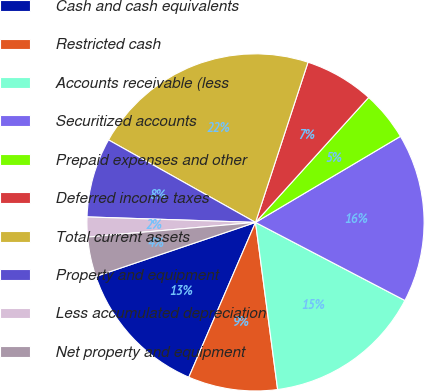Convert chart to OTSL. <chart><loc_0><loc_0><loc_500><loc_500><pie_chart><fcel>Cash and cash equivalents<fcel>Restricted cash<fcel>Accounts receivable (less<fcel>Securitized accounts<fcel>Prepaid expenses and other<fcel>Deferred income taxes<fcel>Total current assets<fcel>Property and equipment<fcel>Less accumulated depreciation<fcel>Net property and equipment<nl><fcel>13.33%<fcel>8.57%<fcel>15.24%<fcel>16.19%<fcel>4.76%<fcel>6.67%<fcel>21.9%<fcel>7.62%<fcel>1.9%<fcel>3.81%<nl></chart> 